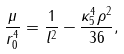Convert formula to latex. <formula><loc_0><loc_0><loc_500><loc_500>\frac { \mu } { r _ { 0 } ^ { 4 } } = \frac { 1 } { l ^ { 2 } } - \frac { \kappa _ { 5 } ^ { 4 } \rho ^ { 2 } } { 3 6 } ,</formula> 